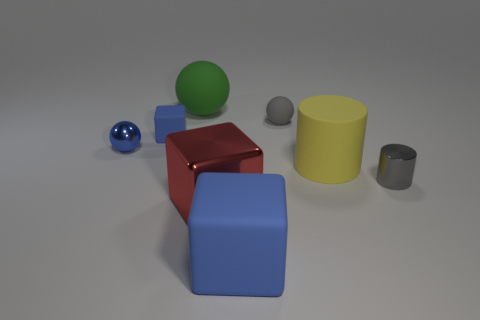There is a blue rubber thing that is the same size as the green ball; what is its shape?
Offer a very short reply. Cube. There is a cylinder that is left of the tiny gray cylinder; how big is it?
Ensure brevity in your answer.  Large. There is a tiny metal object that is behind the tiny gray cylinder; is it the same color as the rubber cube in front of the large yellow cylinder?
Provide a succinct answer. Yes. The block that is behind the cylinder that is to the left of the tiny metallic object right of the big red shiny block is made of what material?
Your answer should be compact. Rubber. Is there a metal cylinder of the same size as the red block?
Make the answer very short. No. There is a blue block that is the same size as the shiny sphere; what is it made of?
Provide a short and direct response. Rubber. There is a big matte object in front of the yellow thing; what shape is it?
Keep it short and to the point. Cube. Is the material of the small gray object that is behind the large yellow object the same as the cylinder to the left of the tiny gray cylinder?
Ensure brevity in your answer.  Yes. How many big green matte things have the same shape as the gray shiny object?
Ensure brevity in your answer.  0. There is a tiny thing that is the same color as the small metallic ball; what is it made of?
Offer a terse response. Rubber. 